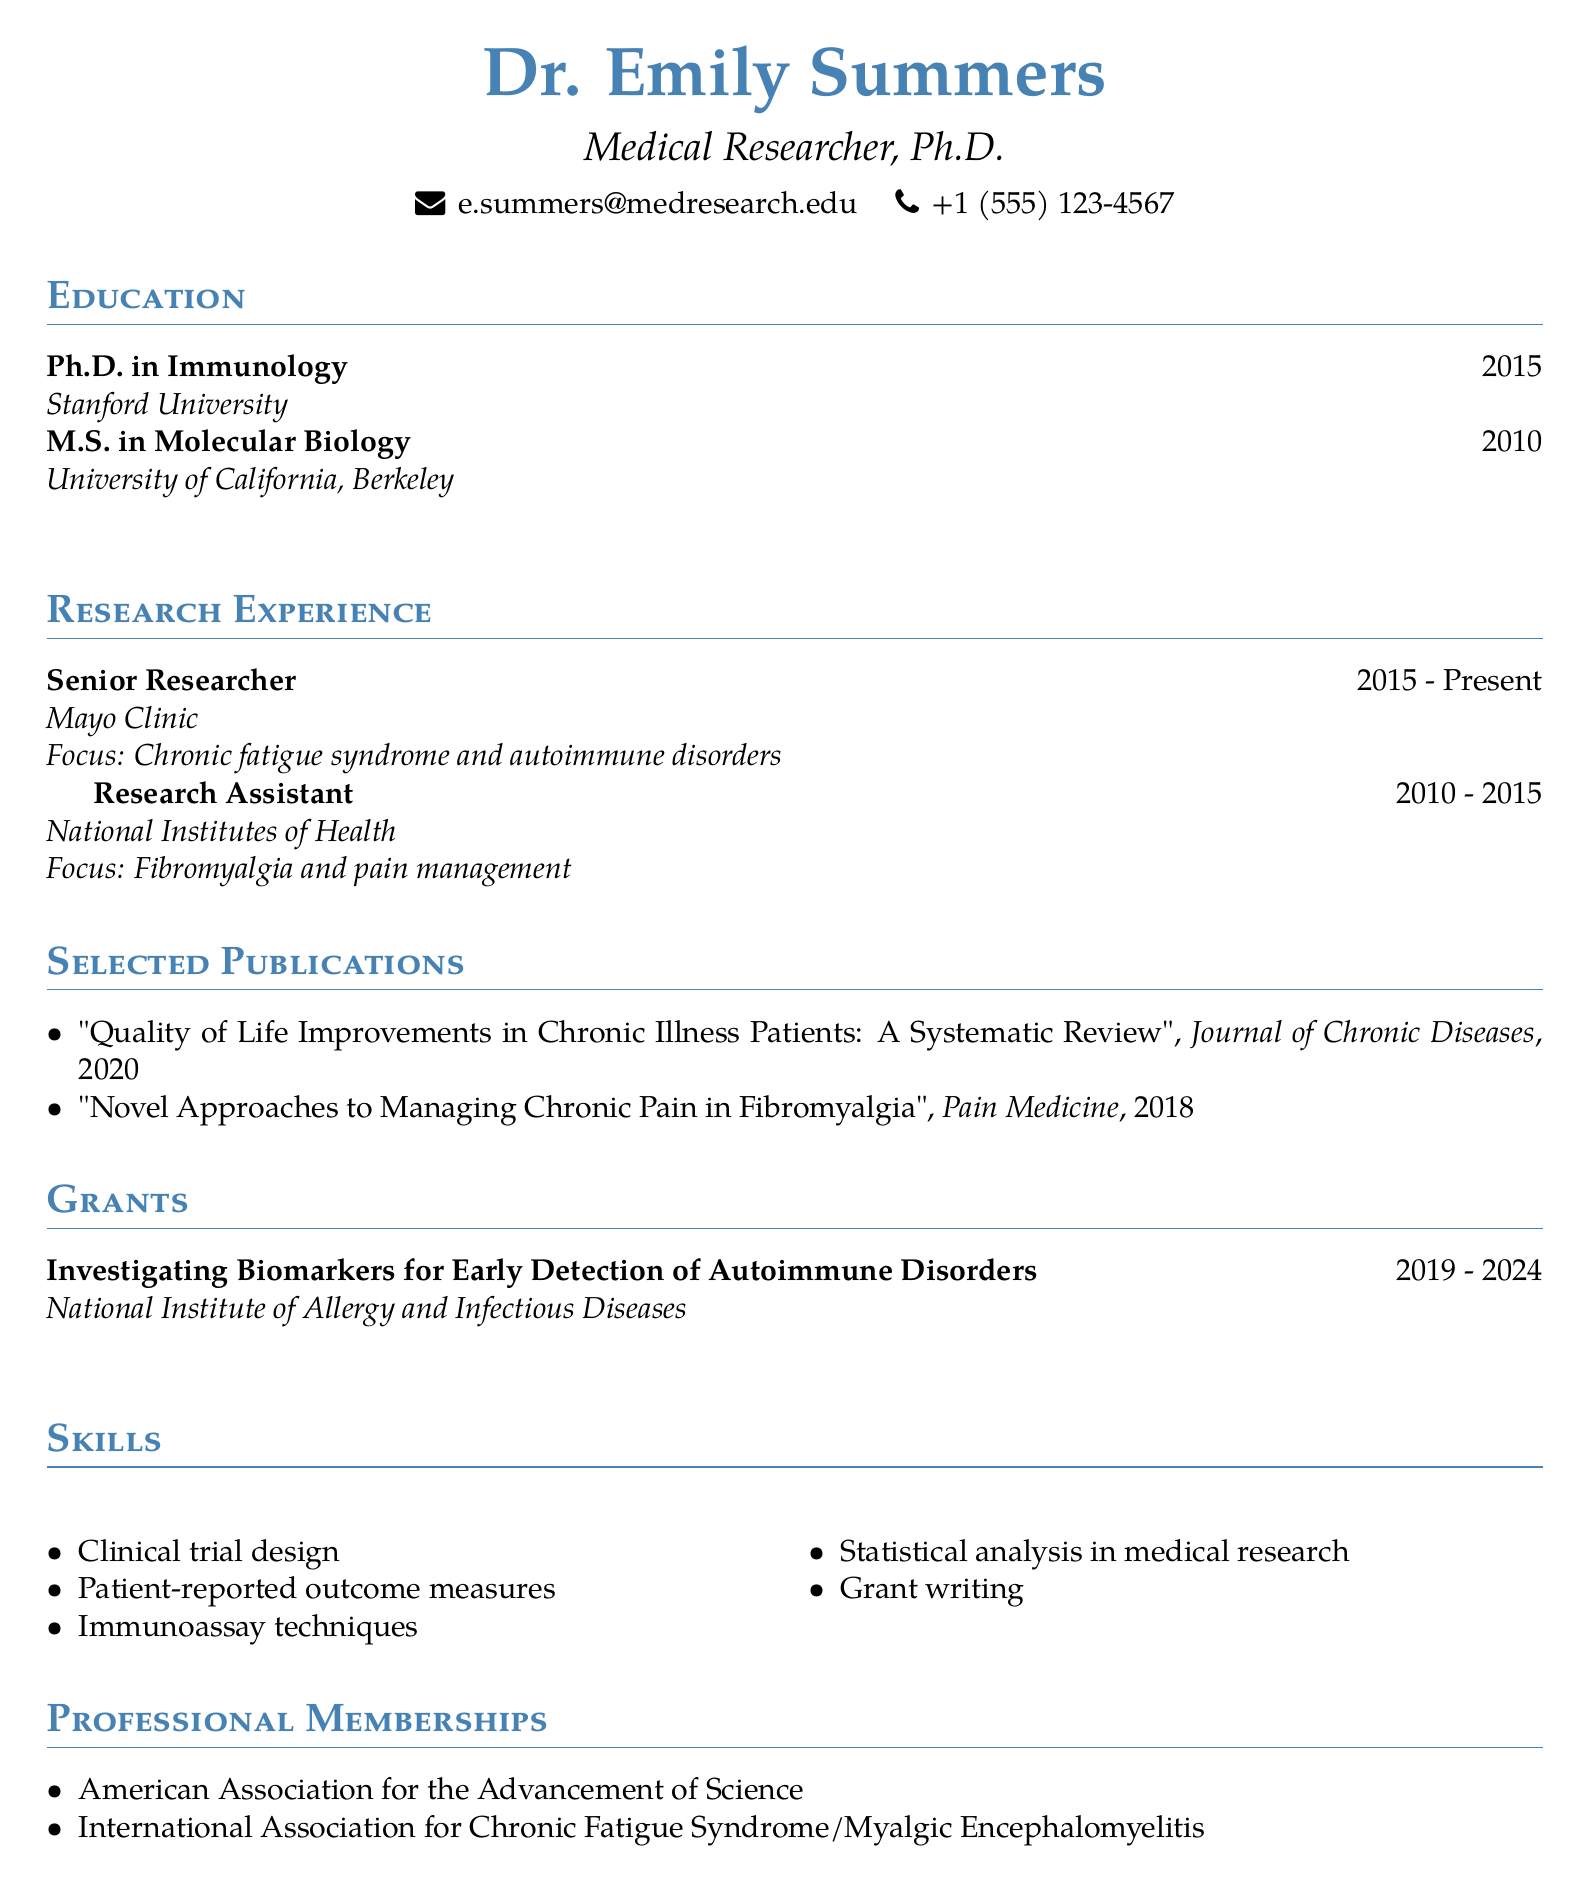What is the name of the researcher? The name of the researcher is prominently displayed at the top of the document.
Answer: Dr. Emily Summers What is the highest degree obtained by the researcher? The highest degree listed in the education section is indicative of her academic achievement.
Answer: Ph.D. in Immunology What institution did the researcher attend for their Master's degree? The institution for the Master's degree is mentioned in the education section.
Answer: University of California, Berkeley In which journal was the publication about chronic illness quality of life published? The journal name is stated next to the publication title in the selected publications section.
Answer: Journal of Chronic Diseases What is the main focus of Dr. Summers' research at the Mayo Clinic? The focus of her current research can be found in the research experience section.
Answer: Chronic fatigue syndrome and autoimmune disorders How many years of research experience does the researcher have at the Mayo Clinic? The duration mentioned in the document gives the length of experience.
Answer: 8 years What grant is currently being funded, and by which agency? The title and agency for the grant are provided in the grants section.
Answer: Investigating Biomarkers for Early Detection of Autoimmune Disorders, National Institute of Allergy and Infectious Diseases Which professional membership is specifically related to Chronic Fatigue Syndrome? The membership demonstrates her involvement in specific research fields mentioned in the document.
Answer: International Association for Chronic Fatigue Syndrome/Myalgic Encephalomyelitis What year was the publication on chronic pain in fibromyalgia released? The publication year is noted next to the title in the selected publications section.
Answer: 2018 